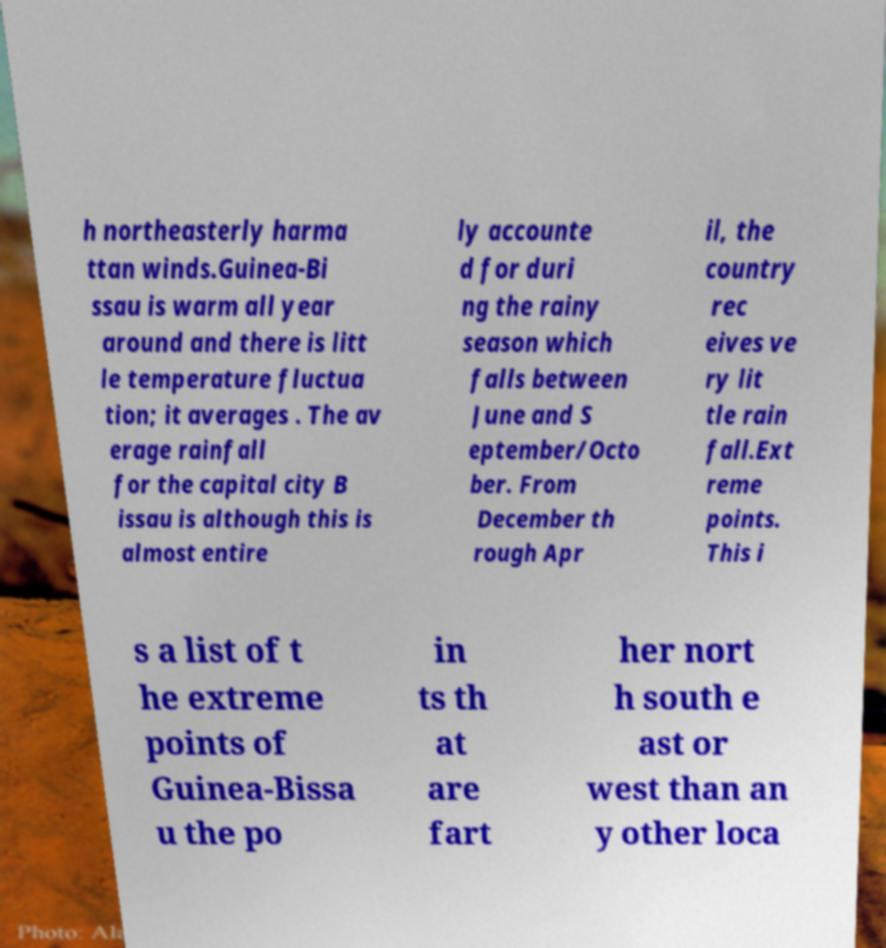For documentation purposes, I need the text within this image transcribed. Could you provide that? h northeasterly harma ttan winds.Guinea-Bi ssau is warm all year around and there is litt le temperature fluctua tion; it averages . The av erage rainfall for the capital city B issau is although this is almost entire ly accounte d for duri ng the rainy season which falls between June and S eptember/Octo ber. From December th rough Apr il, the country rec eives ve ry lit tle rain fall.Ext reme points. This i s a list of t he extreme points of Guinea-Bissa u the po in ts th at are fart her nort h south e ast or west than an y other loca 